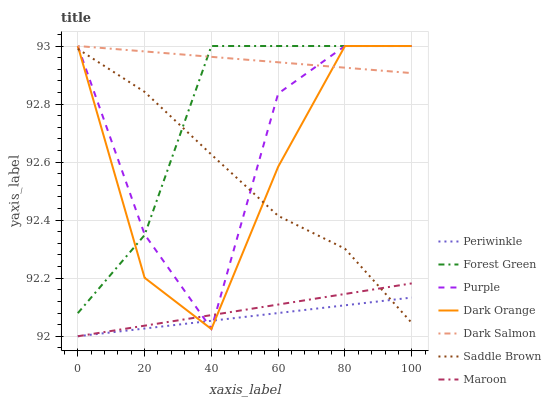Does Periwinkle have the minimum area under the curve?
Answer yes or no. Yes. Does Dark Salmon have the maximum area under the curve?
Answer yes or no. Yes. Does Purple have the minimum area under the curve?
Answer yes or no. No. Does Purple have the maximum area under the curve?
Answer yes or no. No. Is Periwinkle the smoothest?
Answer yes or no. Yes. Is Purple the roughest?
Answer yes or no. Yes. Is Dark Salmon the smoothest?
Answer yes or no. No. Is Dark Salmon the roughest?
Answer yes or no. No. Does Maroon have the lowest value?
Answer yes or no. Yes. Does Purple have the lowest value?
Answer yes or no. No. Does Forest Green have the highest value?
Answer yes or no. Yes. Does Maroon have the highest value?
Answer yes or no. No. Is Saddle Brown less than Dark Salmon?
Answer yes or no. Yes. Is Forest Green greater than Maroon?
Answer yes or no. Yes. Does Purple intersect Dark Orange?
Answer yes or no. Yes. Is Purple less than Dark Orange?
Answer yes or no. No. Is Purple greater than Dark Orange?
Answer yes or no. No. Does Saddle Brown intersect Dark Salmon?
Answer yes or no. No. 